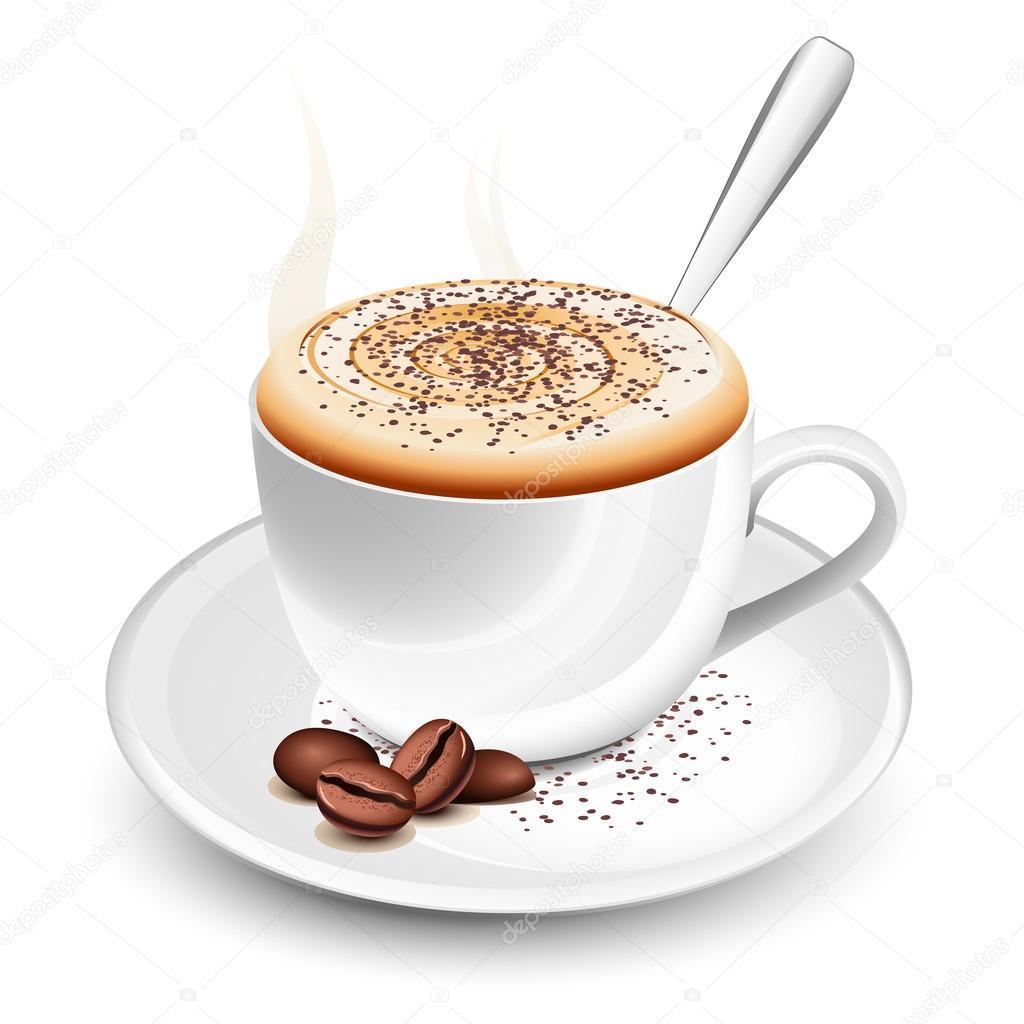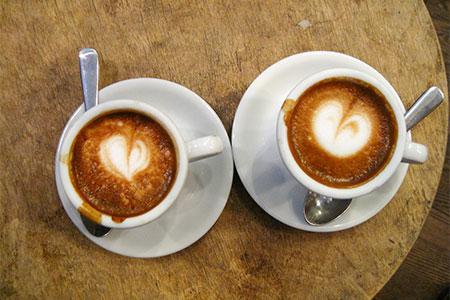The first image is the image on the left, the second image is the image on the right. Evaluate the accuracy of this statement regarding the images: "Several coffee beans are near a white cup of steaming beverage on a white saucer.". Is it true? Answer yes or no. Yes. The first image is the image on the left, the second image is the image on the right. For the images displayed, is the sentence "All of the mugs are sitting on saucers." factually correct? Answer yes or no. Yes. 